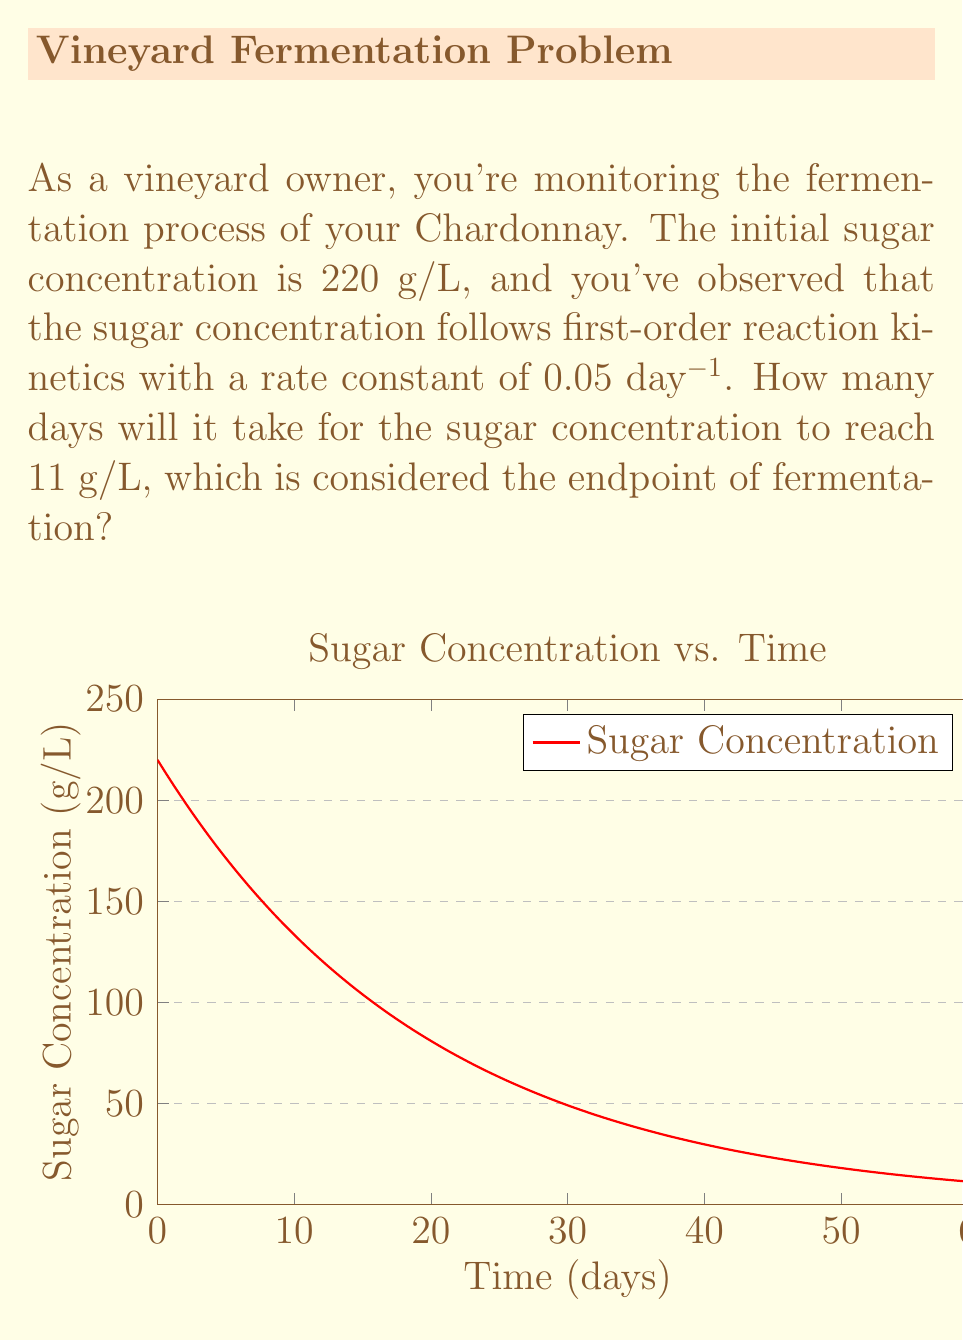Can you answer this question? Let's approach this step-by-step using first-order reaction kinetics:

1) The first-order reaction rate equation is:

   $$\frac{dC}{dt} = -kC$$

   where $C$ is the concentration, $t$ is time, and $k$ is the rate constant.

2) Integrating this equation gives us:

   $$\ln\frac{C}{C_0} = -kt$$

   where $C_0$ is the initial concentration.

3) We can rearrange this to solve for $t$:

   $$t = -\frac{1}{k}\ln\frac{C}{C_0}$$

4) Now, let's plug in our values:
   $C_0 = 220$ g/L (initial concentration)
   $C = 11$ g/L (final concentration)
   $k = 0.05$ day⁻¹ (rate constant)

5) Substituting these into our equation:

   $$t = -\frac{1}{0.05}\ln\frac{11}{220}$$

6) Simplifying:

   $$t = -20\ln(0.05)$$

7) Calculating:

   $$t \approx 59.91 \text{ days}$$

8) Rounding to the nearest day:

   $$t = 60 \text{ days}$$
Answer: 60 days 